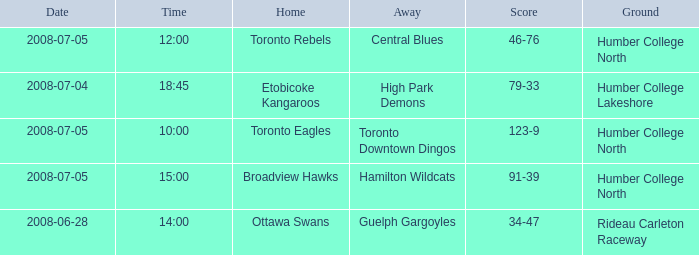What is the Date with a Time that is 18:45? 2008-07-04. 